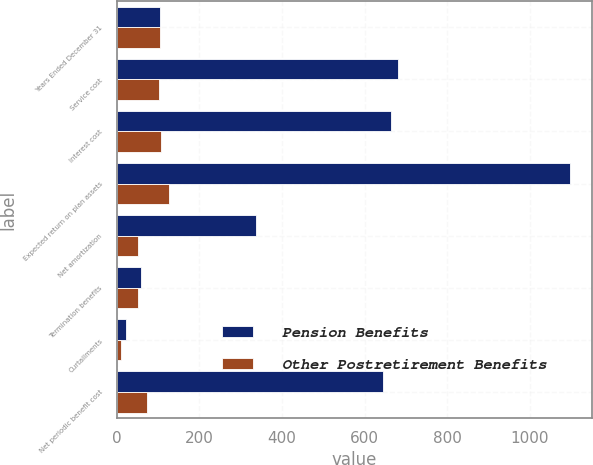Convert chart to OTSL. <chart><loc_0><loc_0><loc_500><loc_500><stacked_bar_chart><ecel><fcel>Years Ended December 31<fcel>Service cost<fcel>Interest cost<fcel>Expected return on plan assets<fcel>Net amortization<fcel>Termination benefits<fcel>Curtailments<fcel>Net periodic benefit cost<nl><fcel>Pension Benefits<fcel>104.5<fcel>682<fcel>665<fcel>1097<fcel>336<fcel>58<fcel>23<fcel>644<nl><fcel>Other Postretirement Benefits<fcel>104.5<fcel>102<fcel>107<fcel>126<fcel>50<fcel>50<fcel>11<fcel>72<nl></chart> 